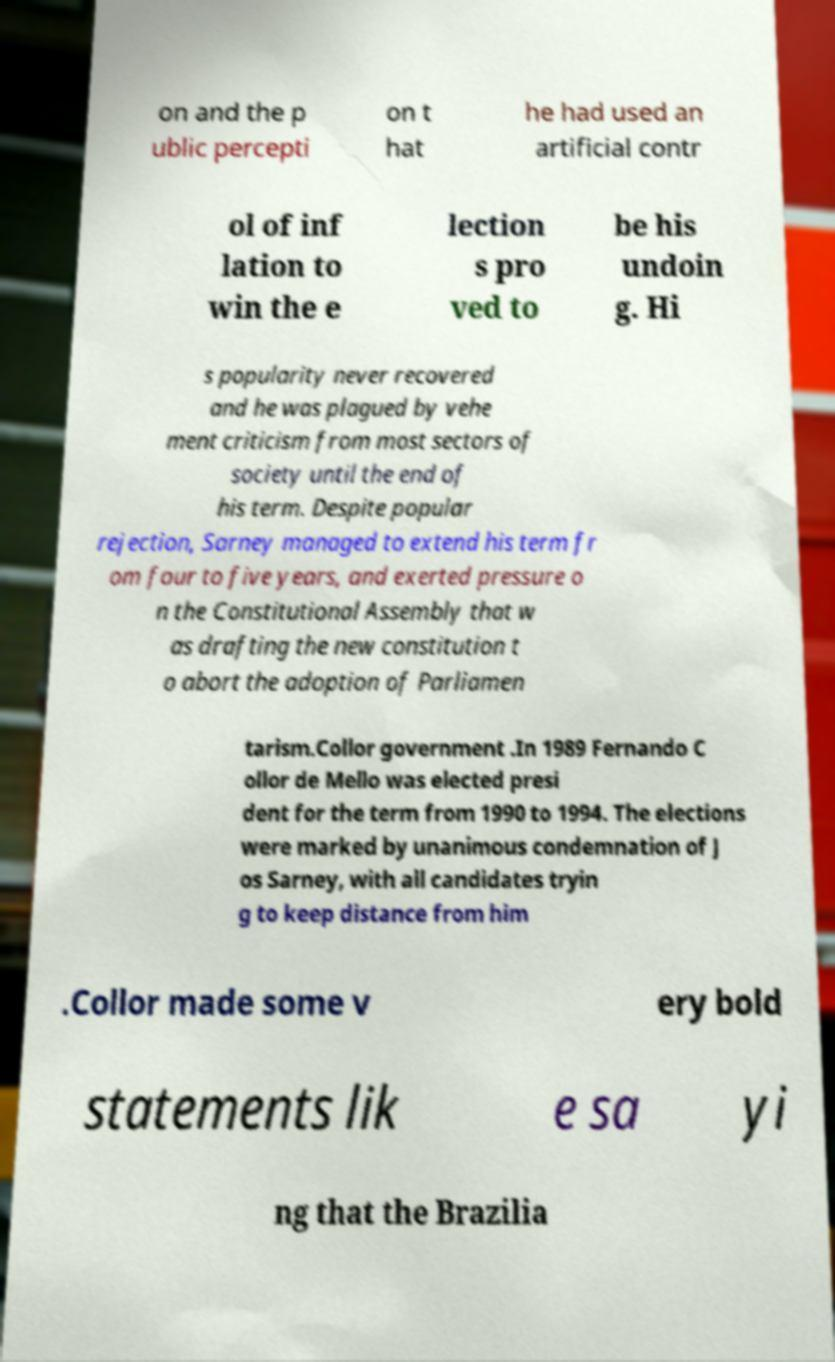Can you accurately transcribe the text from the provided image for me? The image shows a document with partial visibility of the text due to blurring. Here is a transcription of the text that can be deciphered: '...and the public perception that he had used an artificial control of inflation to win the elections proved to be his undoing. His popularity never recovered and he was plagued by vehement criticism from most sectors of society until the end of his term. Despite popular rejection, Sarney managed to extend his term from four to five years and exerted pressure on the Constitutional Assembly that was drafting the new constitution to abort the adoption of Parliamentarianism. Collor government. In 1989 Fernando Collor de Mello was elected president for the term from 1990 to 1994. The elections were marked by unanimous condemnation of Jos� Sarney, with all candidates trying to keep distance from him. Collor made some very bold statements like saying that the Brazilian...' 